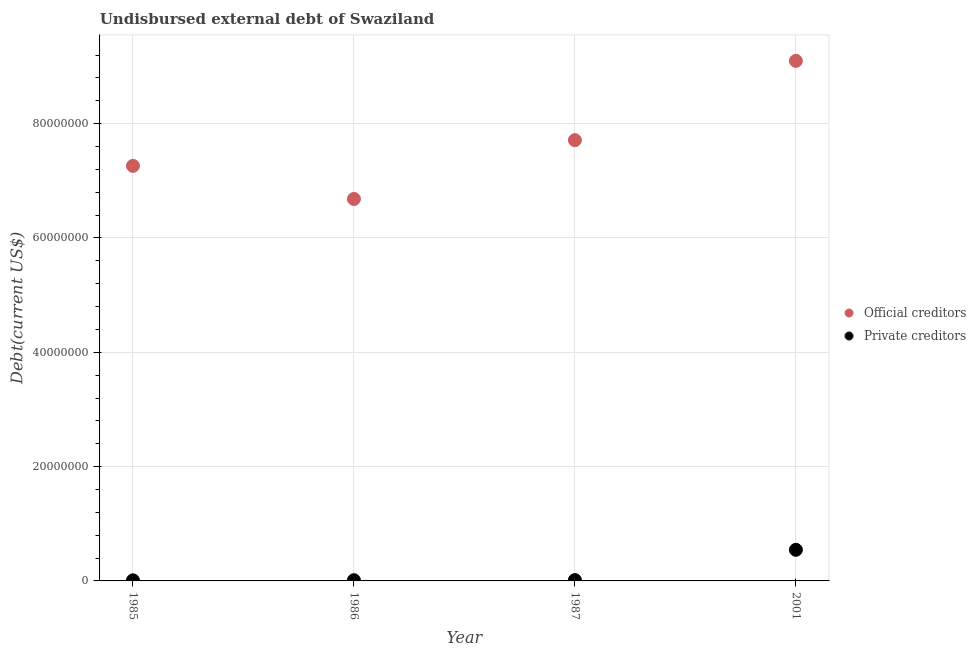How many different coloured dotlines are there?
Give a very brief answer. 2. What is the undisbursed external debt of private creditors in 2001?
Give a very brief answer. 5.44e+06. Across all years, what is the maximum undisbursed external debt of official creditors?
Ensure brevity in your answer.  9.10e+07. Across all years, what is the minimum undisbursed external debt of official creditors?
Provide a succinct answer. 6.68e+07. In which year was the undisbursed external debt of official creditors maximum?
Your answer should be very brief. 2001. In which year was the undisbursed external debt of private creditors minimum?
Your answer should be very brief. 1985. What is the total undisbursed external debt of official creditors in the graph?
Keep it short and to the point. 3.08e+08. What is the difference between the undisbursed external debt of official creditors in 1986 and that in 1987?
Keep it short and to the point. -1.03e+07. What is the difference between the undisbursed external debt of private creditors in 1985 and the undisbursed external debt of official creditors in 1986?
Ensure brevity in your answer.  -6.67e+07. What is the average undisbursed external debt of private creditors per year?
Give a very brief answer. 1.45e+06. In the year 1986, what is the difference between the undisbursed external debt of official creditors and undisbursed external debt of private creditors?
Keep it short and to the point. 6.67e+07. What is the ratio of the undisbursed external debt of official creditors in 1987 to that in 2001?
Offer a very short reply. 0.85. Is the difference between the undisbursed external debt of official creditors in 1985 and 2001 greater than the difference between the undisbursed external debt of private creditors in 1985 and 2001?
Ensure brevity in your answer.  No. What is the difference between the highest and the second highest undisbursed external debt of official creditors?
Provide a succinct answer. 1.39e+07. What is the difference between the highest and the lowest undisbursed external debt of official creditors?
Your answer should be very brief. 2.42e+07. In how many years, is the undisbursed external debt of private creditors greater than the average undisbursed external debt of private creditors taken over all years?
Ensure brevity in your answer.  1. Is the sum of the undisbursed external debt of official creditors in 1985 and 1987 greater than the maximum undisbursed external debt of private creditors across all years?
Your answer should be compact. Yes. Is the undisbursed external debt of private creditors strictly greater than the undisbursed external debt of official creditors over the years?
Your answer should be compact. No. Is the undisbursed external debt of official creditors strictly less than the undisbursed external debt of private creditors over the years?
Offer a terse response. No. How many years are there in the graph?
Ensure brevity in your answer.  4. Are the values on the major ticks of Y-axis written in scientific E-notation?
Make the answer very short. No. Where does the legend appear in the graph?
Provide a succinct answer. Center right. How many legend labels are there?
Make the answer very short. 2. How are the legend labels stacked?
Offer a terse response. Vertical. What is the title of the graph?
Offer a very short reply. Undisbursed external debt of Swaziland. Does "Nitrous oxide" appear as one of the legend labels in the graph?
Offer a very short reply. No. What is the label or title of the X-axis?
Give a very brief answer. Year. What is the label or title of the Y-axis?
Offer a terse response. Debt(current US$). What is the Debt(current US$) in Official creditors in 1985?
Offer a very short reply. 7.26e+07. What is the Debt(current US$) of Private creditors in 1985?
Your response must be concise. 1.03e+05. What is the Debt(current US$) of Official creditors in 1986?
Make the answer very short. 6.68e+07. What is the Debt(current US$) in Private creditors in 1986?
Your answer should be very brief. 1.21e+05. What is the Debt(current US$) in Official creditors in 1987?
Provide a short and direct response. 7.71e+07. What is the Debt(current US$) in Private creditors in 1987?
Ensure brevity in your answer.  1.46e+05. What is the Debt(current US$) in Official creditors in 2001?
Offer a very short reply. 9.10e+07. What is the Debt(current US$) in Private creditors in 2001?
Offer a very short reply. 5.44e+06. Across all years, what is the maximum Debt(current US$) in Official creditors?
Ensure brevity in your answer.  9.10e+07. Across all years, what is the maximum Debt(current US$) in Private creditors?
Offer a very short reply. 5.44e+06. Across all years, what is the minimum Debt(current US$) of Official creditors?
Your answer should be compact. 6.68e+07. Across all years, what is the minimum Debt(current US$) in Private creditors?
Provide a succinct answer. 1.03e+05. What is the total Debt(current US$) in Official creditors in the graph?
Ensure brevity in your answer.  3.08e+08. What is the total Debt(current US$) in Private creditors in the graph?
Your response must be concise. 5.81e+06. What is the difference between the Debt(current US$) of Official creditors in 1985 and that in 1986?
Your answer should be compact. 5.79e+06. What is the difference between the Debt(current US$) of Private creditors in 1985 and that in 1986?
Your answer should be very brief. -1.80e+04. What is the difference between the Debt(current US$) in Official creditors in 1985 and that in 1987?
Offer a terse response. -4.50e+06. What is the difference between the Debt(current US$) of Private creditors in 1985 and that in 1987?
Your answer should be very brief. -4.30e+04. What is the difference between the Debt(current US$) in Official creditors in 1985 and that in 2001?
Your response must be concise. -1.84e+07. What is the difference between the Debt(current US$) in Private creditors in 1985 and that in 2001?
Ensure brevity in your answer.  -5.34e+06. What is the difference between the Debt(current US$) in Official creditors in 1986 and that in 1987?
Make the answer very short. -1.03e+07. What is the difference between the Debt(current US$) of Private creditors in 1986 and that in 1987?
Offer a very short reply. -2.50e+04. What is the difference between the Debt(current US$) of Official creditors in 1986 and that in 2001?
Offer a very short reply. -2.42e+07. What is the difference between the Debt(current US$) of Private creditors in 1986 and that in 2001?
Ensure brevity in your answer.  -5.32e+06. What is the difference between the Debt(current US$) in Official creditors in 1987 and that in 2001?
Provide a succinct answer. -1.39e+07. What is the difference between the Debt(current US$) of Private creditors in 1987 and that in 2001?
Your response must be concise. -5.30e+06. What is the difference between the Debt(current US$) in Official creditors in 1985 and the Debt(current US$) in Private creditors in 1986?
Your answer should be compact. 7.25e+07. What is the difference between the Debt(current US$) of Official creditors in 1985 and the Debt(current US$) of Private creditors in 1987?
Offer a very short reply. 7.25e+07. What is the difference between the Debt(current US$) in Official creditors in 1985 and the Debt(current US$) in Private creditors in 2001?
Your response must be concise. 6.72e+07. What is the difference between the Debt(current US$) in Official creditors in 1986 and the Debt(current US$) in Private creditors in 1987?
Make the answer very short. 6.67e+07. What is the difference between the Debt(current US$) in Official creditors in 1986 and the Debt(current US$) in Private creditors in 2001?
Provide a short and direct response. 6.14e+07. What is the difference between the Debt(current US$) in Official creditors in 1987 and the Debt(current US$) in Private creditors in 2001?
Your answer should be very brief. 7.17e+07. What is the average Debt(current US$) in Official creditors per year?
Ensure brevity in your answer.  7.69e+07. What is the average Debt(current US$) in Private creditors per year?
Keep it short and to the point. 1.45e+06. In the year 1985, what is the difference between the Debt(current US$) of Official creditors and Debt(current US$) of Private creditors?
Offer a very short reply. 7.25e+07. In the year 1986, what is the difference between the Debt(current US$) in Official creditors and Debt(current US$) in Private creditors?
Keep it short and to the point. 6.67e+07. In the year 1987, what is the difference between the Debt(current US$) of Official creditors and Debt(current US$) of Private creditors?
Your response must be concise. 7.70e+07. In the year 2001, what is the difference between the Debt(current US$) of Official creditors and Debt(current US$) of Private creditors?
Offer a very short reply. 8.55e+07. What is the ratio of the Debt(current US$) of Official creditors in 1985 to that in 1986?
Your answer should be compact. 1.09. What is the ratio of the Debt(current US$) of Private creditors in 1985 to that in 1986?
Keep it short and to the point. 0.85. What is the ratio of the Debt(current US$) of Official creditors in 1985 to that in 1987?
Make the answer very short. 0.94. What is the ratio of the Debt(current US$) of Private creditors in 1985 to that in 1987?
Give a very brief answer. 0.71. What is the ratio of the Debt(current US$) in Official creditors in 1985 to that in 2001?
Your answer should be very brief. 0.8. What is the ratio of the Debt(current US$) in Private creditors in 1985 to that in 2001?
Provide a short and direct response. 0.02. What is the ratio of the Debt(current US$) in Official creditors in 1986 to that in 1987?
Your answer should be very brief. 0.87. What is the ratio of the Debt(current US$) in Private creditors in 1986 to that in 1987?
Your answer should be compact. 0.83. What is the ratio of the Debt(current US$) in Official creditors in 1986 to that in 2001?
Provide a succinct answer. 0.73. What is the ratio of the Debt(current US$) of Private creditors in 1986 to that in 2001?
Provide a succinct answer. 0.02. What is the ratio of the Debt(current US$) in Official creditors in 1987 to that in 2001?
Keep it short and to the point. 0.85. What is the ratio of the Debt(current US$) of Private creditors in 1987 to that in 2001?
Keep it short and to the point. 0.03. What is the difference between the highest and the second highest Debt(current US$) in Official creditors?
Your answer should be compact. 1.39e+07. What is the difference between the highest and the second highest Debt(current US$) in Private creditors?
Keep it short and to the point. 5.30e+06. What is the difference between the highest and the lowest Debt(current US$) in Official creditors?
Give a very brief answer. 2.42e+07. What is the difference between the highest and the lowest Debt(current US$) of Private creditors?
Give a very brief answer. 5.34e+06. 